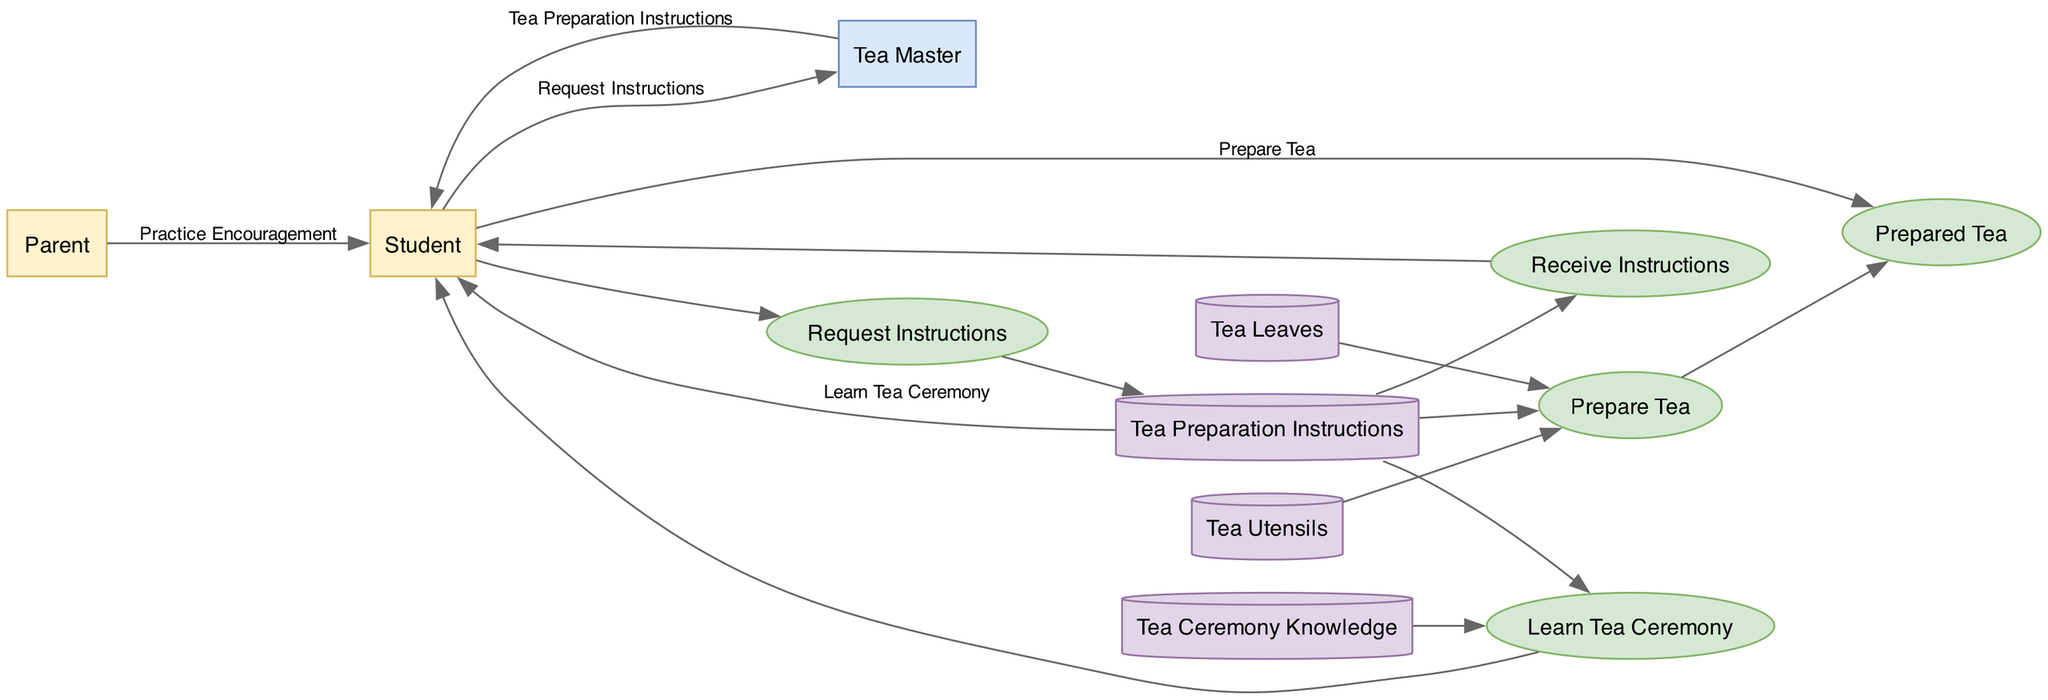What are the external entities in this diagram? The external entities are shown at the left side of the diagram, specifically "Student" and "Parent." These nodes represent the people who interact with the tea ceremony process.
Answer: Student, Parent How many processes are there in the diagram? The diagram outlines four processes: "Request Instructions," "Receive Instructions," "Prepare Tea," and "Learn Tea Ceremony." Counting these, we find there are four distinct processes.
Answer: 4 What data does the Parent send to the Student? The flow from "Parent" to "Student" specifies that the data is "Practice Encouragement." This indicates that the Parent encourages the Student in their learning process.
Answer: Practice Encouragement Which entity outputs the "Tea Preparation Instructions"? The "Tea Master" is responsible for outputting "Tea Preparation Instructions" to the "Student" after receiving a request for instructions.
Answer: Tea Master What is needed for the "Prepare Tea" process? According to the diagram, the "Prepare Tea" process requires three inputs: "Tea Utensils," "Tea Leaves," and "Tea Preparation Instructions" in order to complete the tea preparation.
Answer: Tea Utensils, Tea Leaves, Tea Preparation Instructions Which process is performed by the Student? The processes performed by the Student include "Prepare Tea" and "Learn Tea Ceremony." This indicates the active role of the Student in both preparing the tea and learning about the tea ceremony.
Answer: Prepare Tea, Learn Tea Ceremony What flows from the "Tea Master" to the "Student"? The flow indicates that "Tea Preparation Instructions" move from the "Tea Master" to the "Student," which means the Student receives guidance on how to prepare the tea.
Answer: Tea Preparation Instructions What type of entity is "Tea Leaves"? "Tea Leaves" is classified as a "Data Store" in the diagram. This signifies that it holds essential information required during the tea preparation process.
Answer: Data Store 